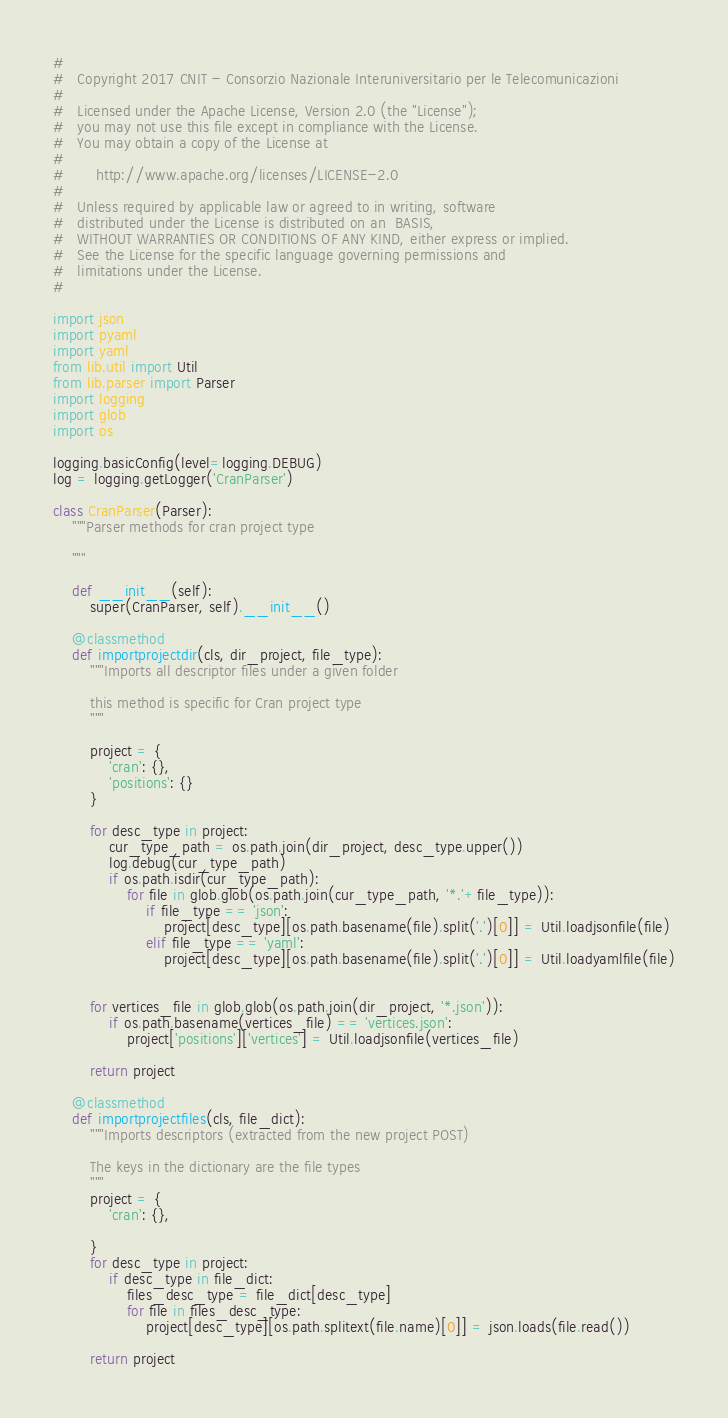Convert code to text. <code><loc_0><loc_0><loc_500><loc_500><_Python_>#
#   Copyright 2017 CNIT - Consorzio Nazionale Interuniversitario per le Telecomunicazioni
#
#   Licensed under the Apache License, Version 2.0 (the "License");
#   you may not use this file except in compliance with the License.
#   You may obtain a copy of the License at
#
#       http://www.apache.org/licenses/LICENSE-2.0
#
#   Unless required by applicable law or agreed to in writing, software
#   distributed under the License is distributed on an  BASIS,
#   WITHOUT WARRANTIES OR CONDITIONS OF ANY KIND, either express or implied.
#   See the License for the specific language governing permissions and
#   limitations under the License.
#

import json
import pyaml
import yaml
from lib.util import Util
from lib.parser import Parser
import logging
import glob
import os

logging.basicConfig(level=logging.DEBUG)
log = logging.getLogger('CranParser')

class CranParser(Parser):
    """Parser methods for cran project type

    """

    def __init__(self):
        super(CranParser, self).__init__()
    
    @classmethod        
    def importprojectdir(cls, dir_project, file_type):
        """Imports all descriptor files under a given folder

        this method is specific for Cran project type
        """

        project = {
            'cran': {},
            'positions': {}
        }

        for desc_type in project:
            cur_type_path = os.path.join(dir_project, desc_type.upper())
            log.debug(cur_type_path)
            if os.path.isdir(cur_type_path):
                for file in glob.glob(os.path.join(cur_type_path, '*.'+file_type)):
                    if file_type == 'json':
                        project[desc_type][os.path.basename(file).split('.')[0]] = Util.loadjsonfile(file)
                    elif file_type == 'yaml':
                        project[desc_type][os.path.basename(file).split('.')[0]] = Util.loadyamlfile(file)


        for vertices_file in glob.glob(os.path.join(dir_project, '*.json')):
            if os.path.basename(vertices_file) == 'vertices.json':
                project['positions']['vertices'] = Util.loadjsonfile(vertices_file)

        return project

    @classmethod
    def importprojectfiles(cls, file_dict):
        """Imports descriptors (extracted from the new project POST)

        The keys in the dictionary are the file types
        """
        project = {
            'cran': {},

        }
        for desc_type in project:
            if desc_type in file_dict:
                files_desc_type = file_dict[desc_type]
                for file in files_desc_type:
                    project[desc_type][os.path.splitext(file.name)[0]] = json.loads(file.read())

        return project</code> 